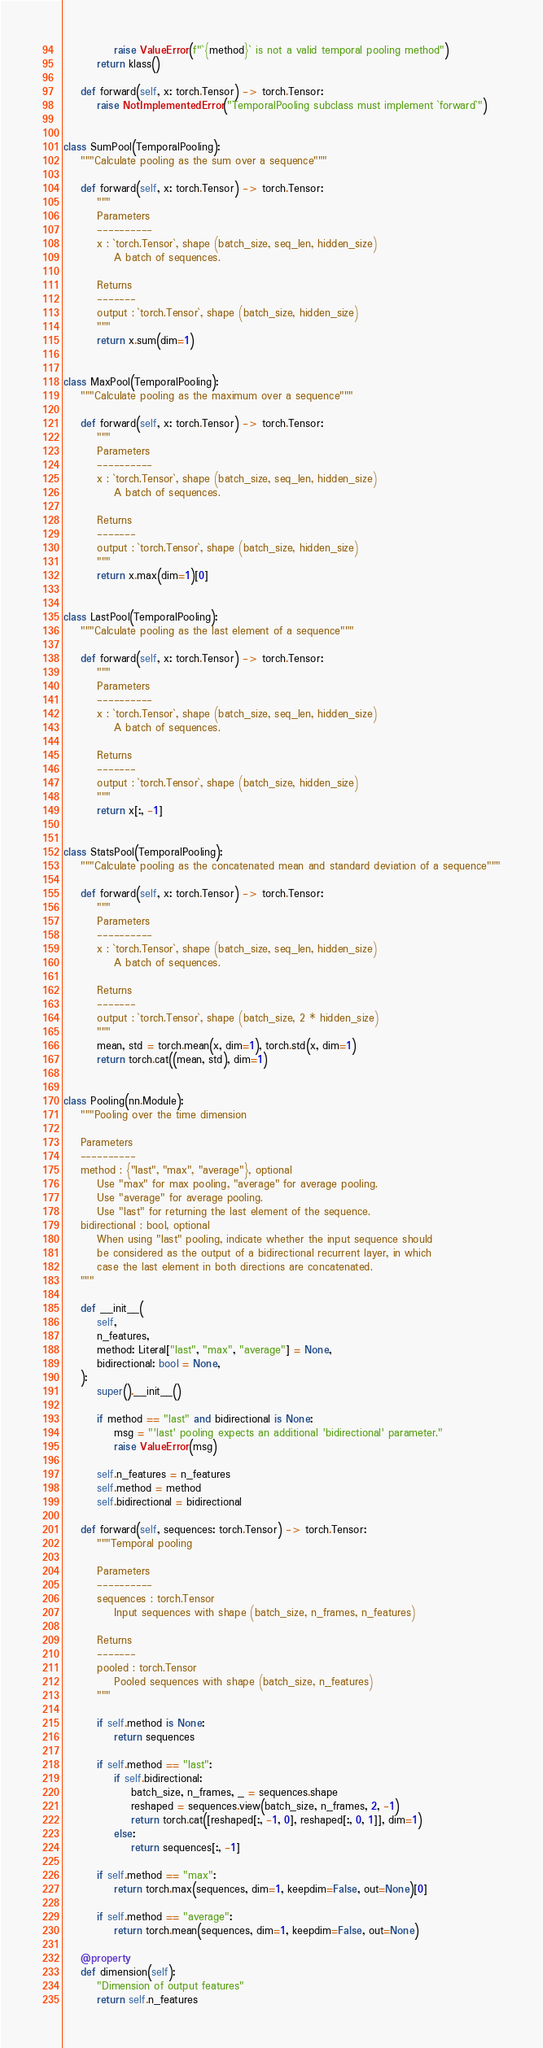Convert code to text. <code><loc_0><loc_0><loc_500><loc_500><_Python_>            raise ValueError(f"`{method}` is not a valid temporal pooling method")
        return klass()

    def forward(self, x: torch.Tensor) -> torch.Tensor:
        raise NotImplementedError("TemporalPooling subclass must implement `forward`")


class SumPool(TemporalPooling):
    """Calculate pooling as the sum over a sequence"""

    def forward(self, x: torch.Tensor) -> torch.Tensor:
        """
        Parameters
        ----------
        x : `torch.Tensor`, shape (batch_size, seq_len, hidden_size)
            A batch of sequences.

        Returns
        -------
        output : `torch.Tensor`, shape (batch_size, hidden_size)
        """
        return x.sum(dim=1)


class MaxPool(TemporalPooling):
    """Calculate pooling as the maximum over a sequence"""

    def forward(self, x: torch.Tensor) -> torch.Tensor:
        """
        Parameters
        ----------
        x : `torch.Tensor`, shape (batch_size, seq_len, hidden_size)
            A batch of sequences.

        Returns
        -------
        output : `torch.Tensor`, shape (batch_size, hidden_size)
        """
        return x.max(dim=1)[0]


class LastPool(TemporalPooling):
    """Calculate pooling as the last element of a sequence"""

    def forward(self, x: torch.Tensor) -> torch.Tensor:
        """
        Parameters
        ----------
        x : `torch.Tensor`, shape (batch_size, seq_len, hidden_size)
            A batch of sequences.

        Returns
        -------
        output : `torch.Tensor`, shape (batch_size, hidden_size)
        """
        return x[:, -1]


class StatsPool(TemporalPooling):
    """Calculate pooling as the concatenated mean and standard deviation of a sequence"""

    def forward(self, x: torch.Tensor) -> torch.Tensor:
        """
        Parameters
        ----------
        x : `torch.Tensor`, shape (batch_size, seq_len, hidden_size)
            A batch of sequences.

        Returns
        -------
        output : `torch.Tensor`, shape (batch_size, 2 * hidden_size)
        """
        mean, std = torch.mean(x, dim=1), torch.std(x, dim=1)
        return torch.cat((mean, std), dim=1)


class Pooling(nn.Module):
    """Pooling over the time dimension

    Parameters
    ----------
    method : {"last", "max", "average"}, optional
        Use "max" for max pooling, "average" for average pooling.
        Use "average" for average pooling.
        Use "last" for returning the last element of the sequence.
    bidirectional : bool, optional
        When using "last" pooling, indicate whether the input sequence should
        be considered as the output of a bidirectional recurrent layer, in which
        case the last element in both directions are concatenated.
    """

    def __init__(
        self,
        n_features,
        method: Literal["last", "max", "average"] = None,
        bidirectional: bool = None,
    ):
        super().__init__()

        if method == "last" and bidirectional is None:
            msg = "'last' pooling expects an additional 'bidirectional' parameter."
            raise ValueError(msg)

        self.n_features = n_features
        self.method = method
        self.bidirectional = bidirectional

    def forward(self, sequences: torch.Tensor) -> torch.Tensor:
        """Temporal pooling

        Parameters
        ----------
        sequences : torch.Tensor
            Input sequences with shape (batch_size, n_frames, n_features)

        Returns
        -------
        pooled : torch.Tensor
            Pooled sequences with shape (batch_size, n_features)
        """

        if self.method is None:
            return sequences

        if self.method == "last":
            if self.bidirectional:
                batch_size, n_frames, _ = sequences.shape
                reshaped = sequences.view(batch_size, n_frames, 2, -1)
                return torch.cat([reshaped[:, -1, 0], reshaped[:, 0, 1]], dim=1)
            else:
                return sequences[:, -1]

        if self.method == "max":
            return torch.max(sequences, dim=1, keepdim=False, out=None)[0]

        if self.method == "average":
            return torch.mean(sequences, dim=1, keepdim=False, out=None)

    @property
    def dimension(self):
        "Dimension of output features"
        return self.n_features
</code> 